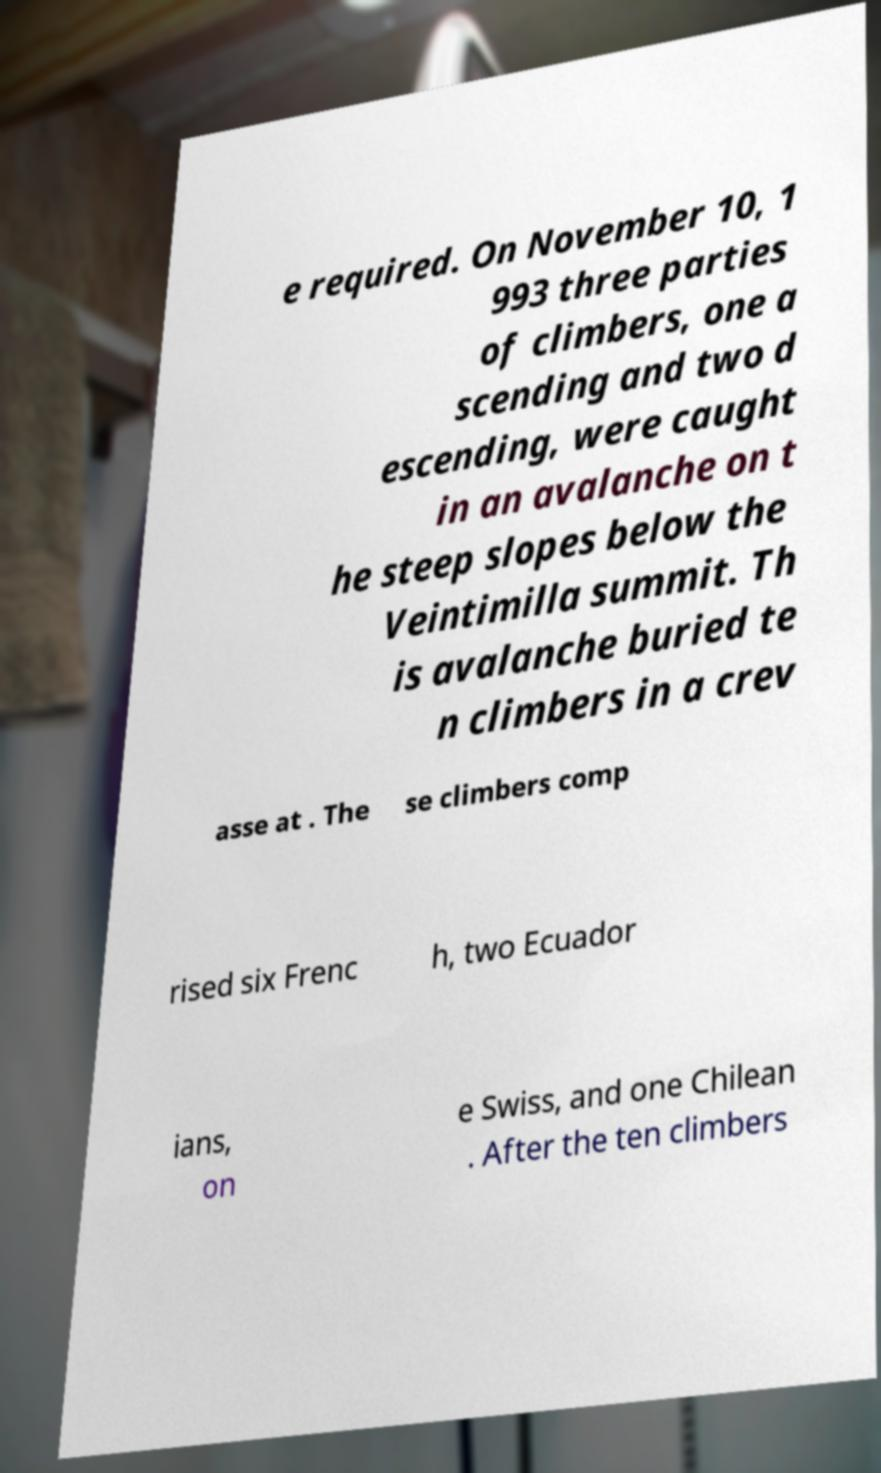I need the written content from this picture converted into text. Can you do that? e required. On November 10, 1 993 three parties of climbers, one a scending and two d escending, were caught in an avalanche on t he steep slopes below the Veintimilla summit. Th is avalanche buried te n climbers in a crev asse at . The se climbers comp rised six Frenc h, two Ecuador ians, on e Swiss, and one Chilean . After the ten climbers 